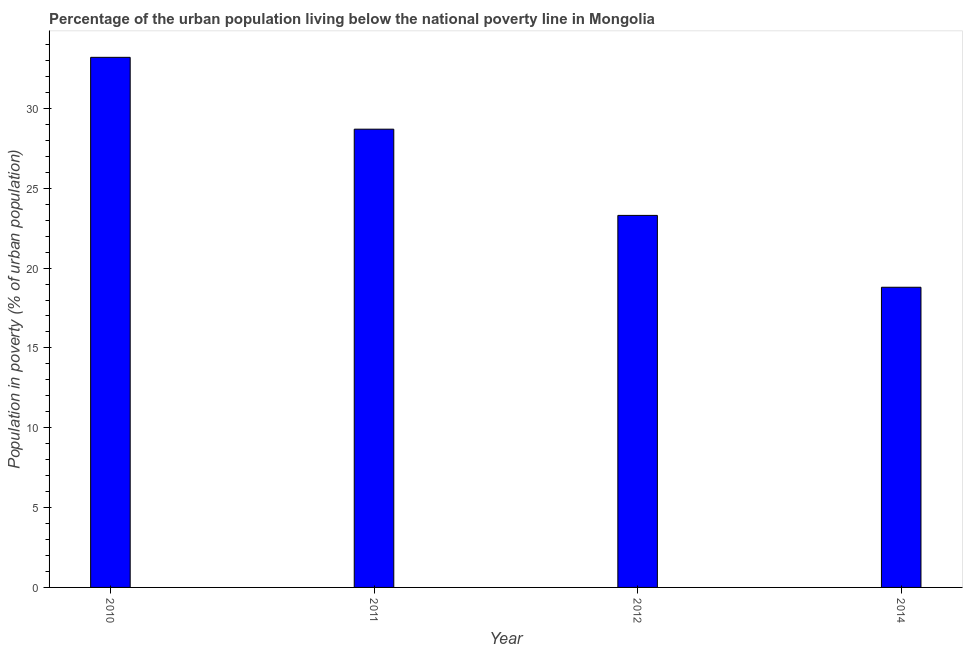What is the title of the graph?
Keep it short and to the point. Percentage of the urban population living below the national poverty line in Mongolia. What is the label or title of the X-axis?
Provide a short and direct response. Year. What is the label or title of the Y-axis?
Your answer should be compact. Population in poverty (% of urban population). What is the percentage of urban population living below poverty line in 2011?
Give a very brief answer. 28.7. Across all years, what is the maximum percentage of urban population living below poverty line?
Provide a short and direct response. 33.2. In which year was the percentage of urban population living below poverty line maximum?
Give a very brief answer. 2010. In which year was the percentage of urban population living below poverty line minimum?
Give a very brief answer. 2014. What is the sum of the percentage of urban population living below poverty line?
Offer a very short reply. 104. What is the difference between the percentage of urban population living below poverty line in 2010 and 2014?
Provide a short and direct response. 14.4. What is the average percentage of urban population living below poverty line per year?
Provide a succinct answer. 26. Do a majority of the years between 2011 and 2012 (inclusive) have percentage of urban population living below poverty line greater than 5 %?
Your answer should be very brief. Yes. What is the ratio of the percentage of urban population living below poverty line in 2010 to that in 2011?
Keep it short and to the point. 1.16. Is the percentage of urban population living below poverty line in 2010 less than that in 2012?
Give a very brief answer. No. How many years are there in the graph?
Ensure brevity in your answer.  4. Are the values on the major ticks of Y-axis written in scientific E-notation?
Provide a succinct answer. No. What is the Population in poverty (% of urban population) in 2010?
Give a very brief answer. 33.2. What is the Population in poverty (% of urban population) in 2011?
Your response must be concise. 28.7. What is the Population in poverty (% of urban population) of 2012?
Keep it short and to the point. 23.3. What is the Population in poverty (% of urban population) in 2014?
Your answer should be very brief. 18.8. What is the difference between the Population in poverty (% of urban population) in 2010 and 2011?
Provide a succinct answer. 4.5. What is the difference between the Population in poverty (% of urban population) in 2010 and 2012?
Make the answer very short. 9.9. What is the difference between the Population in poverty (% of urban population) in 2010 and 2014?
Give a very brief answer. 14.4. What is the difference between the Population in poverty (% of urban population) in 2011 and 2012?
Your response must be concise. 5.4. What is the difference between the Population in poverty (% of urban population) in 2012 and 2014?
Give a very brief answer. 4.5. What is the ratio of the Population in poverty (% of urban population) in 2010 to that in 2011?
Your response must be concise. 1.16. What is the ratio of the Population in poverty (% of urban population) in 2010 to that in 2012?
Ensure brevity in your answer.  1.43. What is the ratio of the Population in poverty (% of urban population) in 2010 to that in 2014?
Offer a very short reply. 1.77. What is the ratio of the Population in poverty (% of urban population) in 2011 to that in 2012?
Provide a short and direct response. 1.23. What is the ratio of the Population in poverty (% of urban population) in 2011 to that in 2014?
Provide a succinct answer. 1.53. What is the ratio of the Population in poverty (% of urban population) in 2012 to that in 2014?
Offer a very short reply. 1.24. 